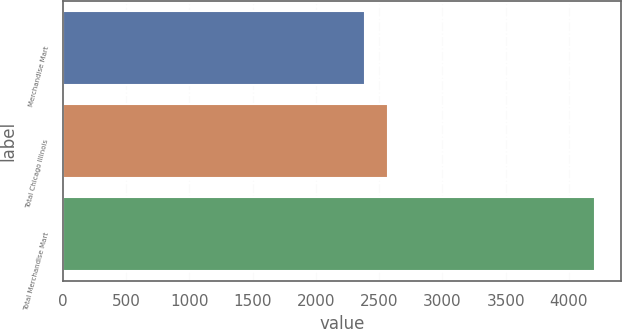<chart> <loc_0><loc_0><loc_500><loc_500><bar_chart><fcel>Merchandise Mart<fcel>Total Chicago Illinois<fcel>Total Merchandise Mart<nl><fcel>2392<fcel>2573.2<fcel>4204<nl></chart> 